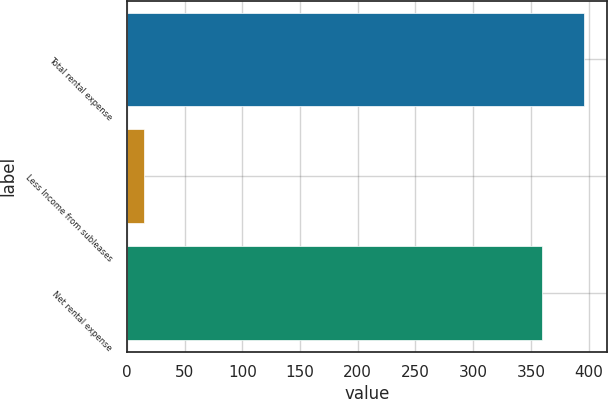<chart> <loc_0><loc_0><loc_500><loc_500><bar_chart><fcel>Total rental expense<fcel>Less Income from subleases<fcel>Net rental expense<nl><fcel>396<fcel>15<fcel>360<nl></chart> 